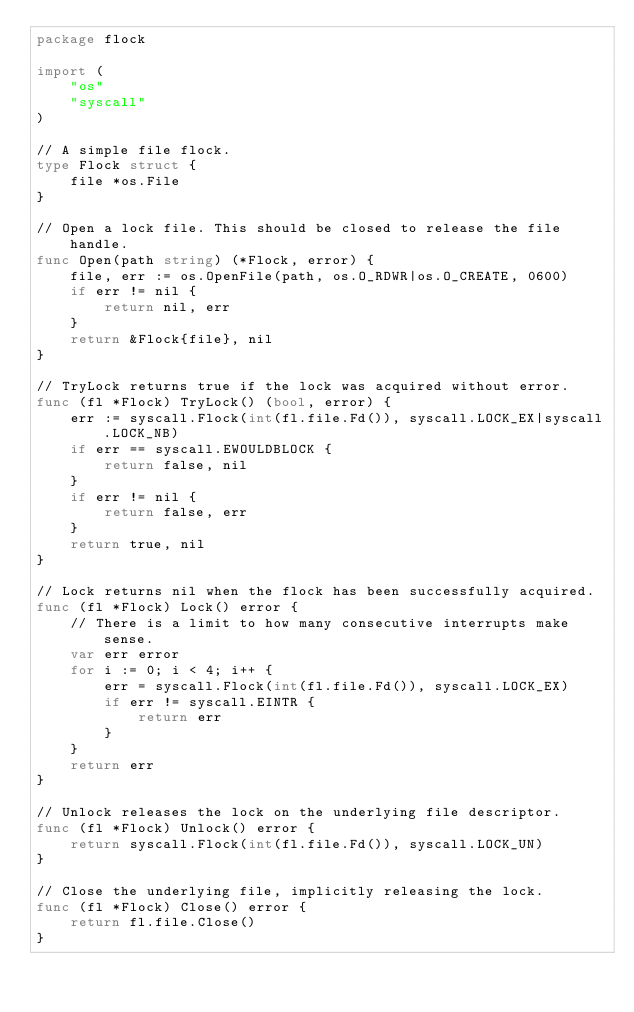Convert code to text. <code><loc_0><loc_0><loc_500><loc_500><_Go_>package flock

import (
	"os"
	"syscall"
)

// A simple file flock.
type Flock struct {
	file *os.File
}

// Open a lock file. This should be closed to release the file handle.
func Open(path string) (*Flock, error) {
	file, err := os.OpenFile(path, os.O_RDWR|os.O_CREATE, 0600)
	if err != nil {
		return nil, err
	}
	return &Flock{file}, nil
}

// TryLock returns true if the lock was acquired without error.
func (fl *Flock) TryLock() (bool, error) {
	err := syscall.Flock(int(fl.file.Fd()), syscall.LOCK_EX|syscall.LOCK_NB)
	if err == syscall.EWOULDBLOCK {
		return false, nil
	}
	if err != nil {
		return false, err
	}
	return true, nil
}

// Lock returns nil when the flock has been successfully acquired.
func (fl *Flock) Lock() error {
	// There is a limit to how many consecutive interrupts make sense.
	var err error
	for i := 0; i < 4; i++ {
		err = syscall.Flock(int(fl.file.Fd()), syscall.LOCK_EX)
		if err != syscall.EINTR {
			return err
		}
	}
	return err
}

// Unlock releases the lock on the underlying file descriptor.
func (fl *Flock) Unlock() error {
	return syscall.Flock(int(fl.file.Fd()), syscall.LOCK_UN)
}

// Close the underlying file, implicitly releasing the lock.
func (fl *Flock) Close() error {
	return fl.file.Close()
}
</code> 